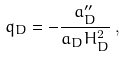Convert formula to latex. <formula><loc_0><loc_0><loc_500><loc_500>q _ { D } = - \frac { a ^ { \prime \prime } _ { D } } { a _ { D } H _ { D } ^ { 2 } } \, ,</formula> 